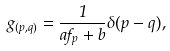<formula> <loc_0><loc_0><loc_500><loc_500>g _ { ( p , q ) } = \frac { 1 } { a f _ { p } + b } \delta ( p - q ) ,</formula> 